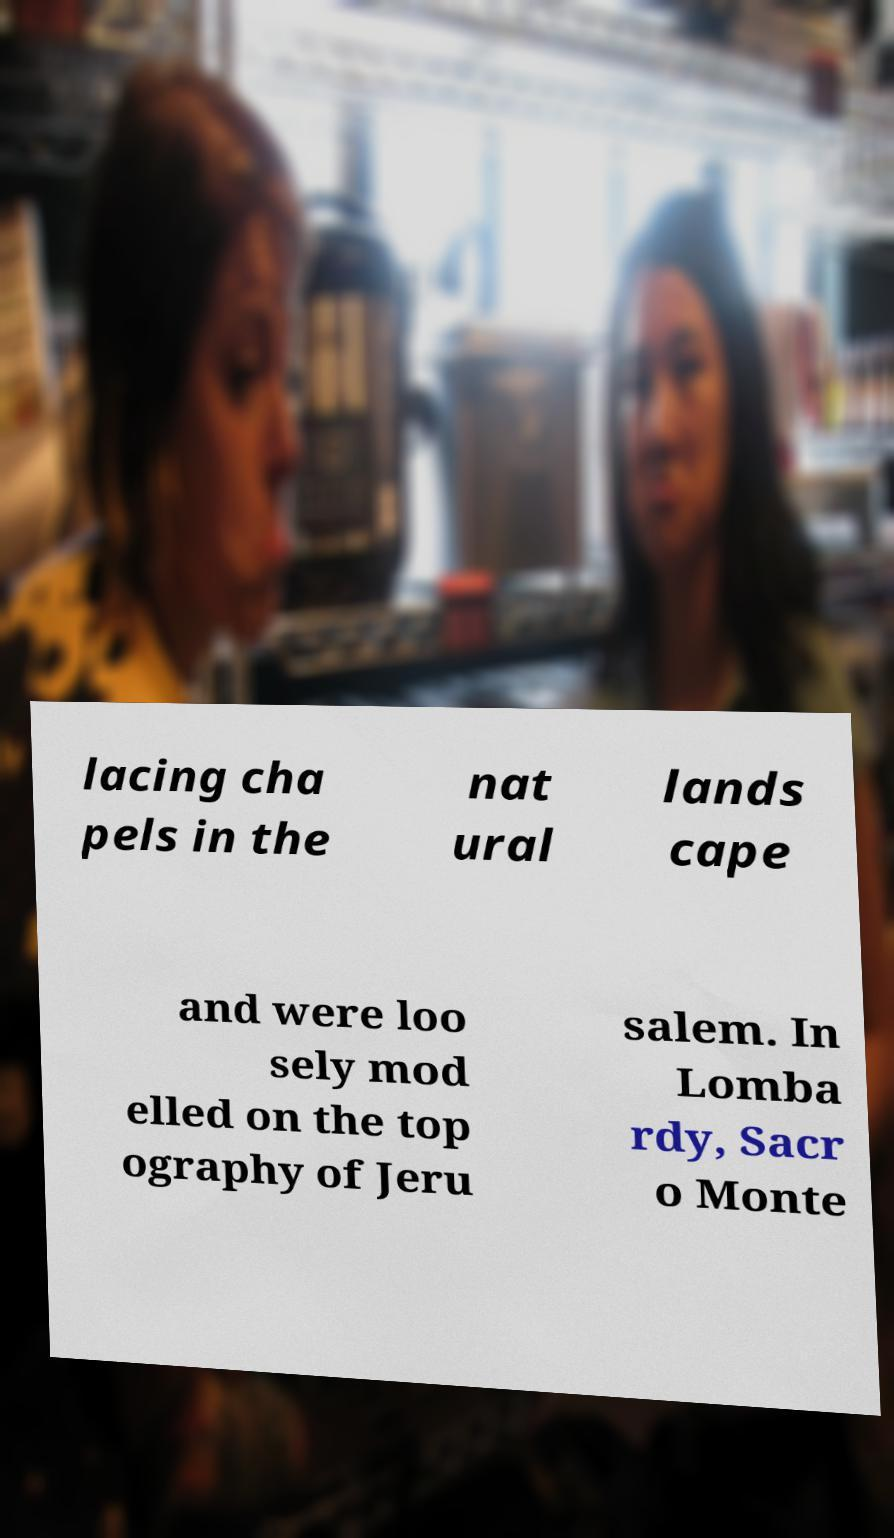Can you accurately transcribe the text from the provided image for me? lacing cha pels in the nat ural lands cape and were loo sely mod elled on the top ography of Jeru salem. In Lomba rdy, Sacr o Monte 